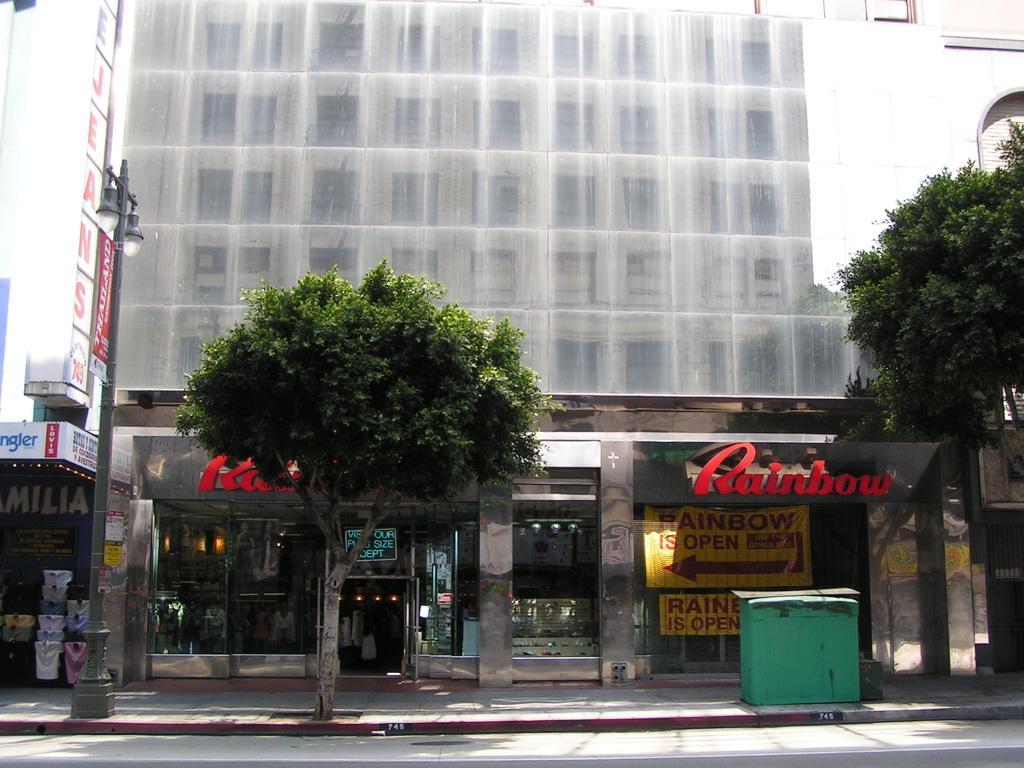How would you summarize this image in a sentence or two? In the image we can see there are trees and there is a street light pole on the footpath. Behind there are buildings and it's written ¨Rainbow¨ on the hoarding of the building. 